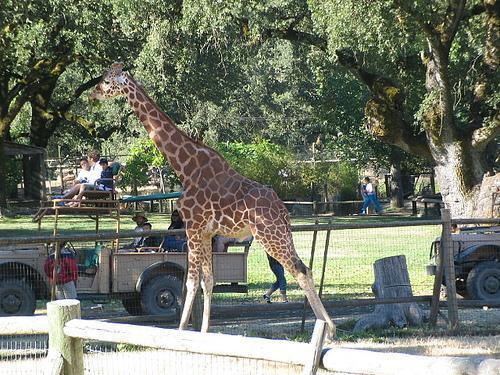How many vehicles are in this photo?
Give a very brief answer. 2. 